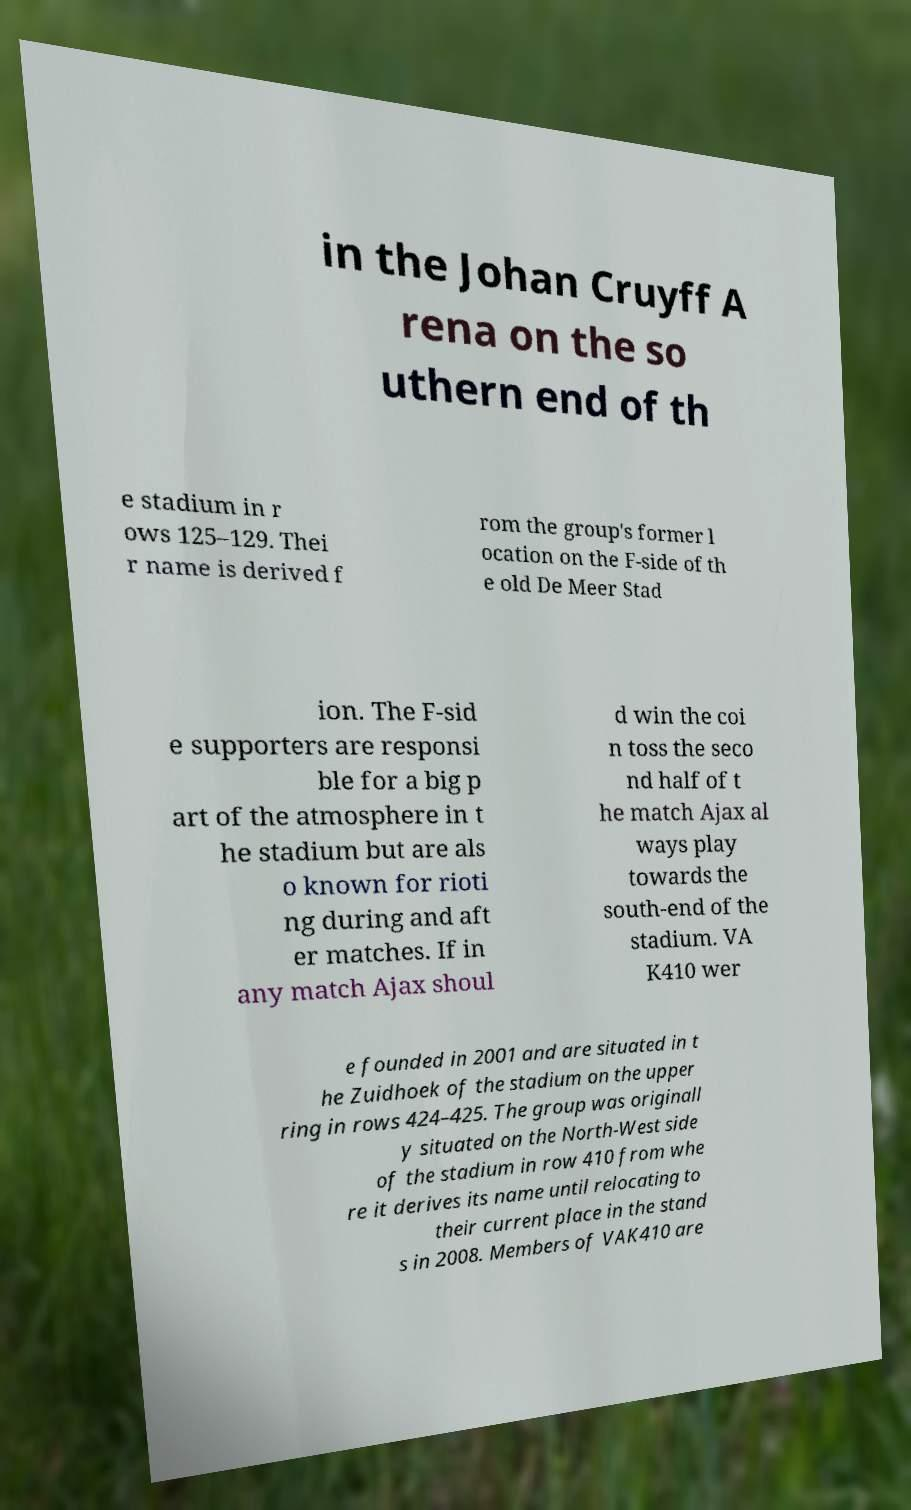Can you accurately transcribe the text from the provided image for me? in the Johan Cruyff A rena on the so uthern end of th e stadium in r ows 125–129. Thei r name is derived f rom the group's former l ocation on the F-side of th e old De Meer Stad ion. The F-sid e supporters are responsi ble for a big p art of the atmosphere in t he stadium but are als o known for rioti ng during and aft er matches. If in any match Ajax shoul d win the coi n toss the seco nd half of t he match Ajax al ways play towards the south-end of the stadium. VA K410 wer e founded in 2001 and are situated in t he Zuidhoek of the stadium on the upper ring in rows 424–425. The group was originall y situated on the North-West side of the stadium in row 410 from whe re it derives its name until relocating to their current place in the stand s in 2008. Members of VAK410 are 